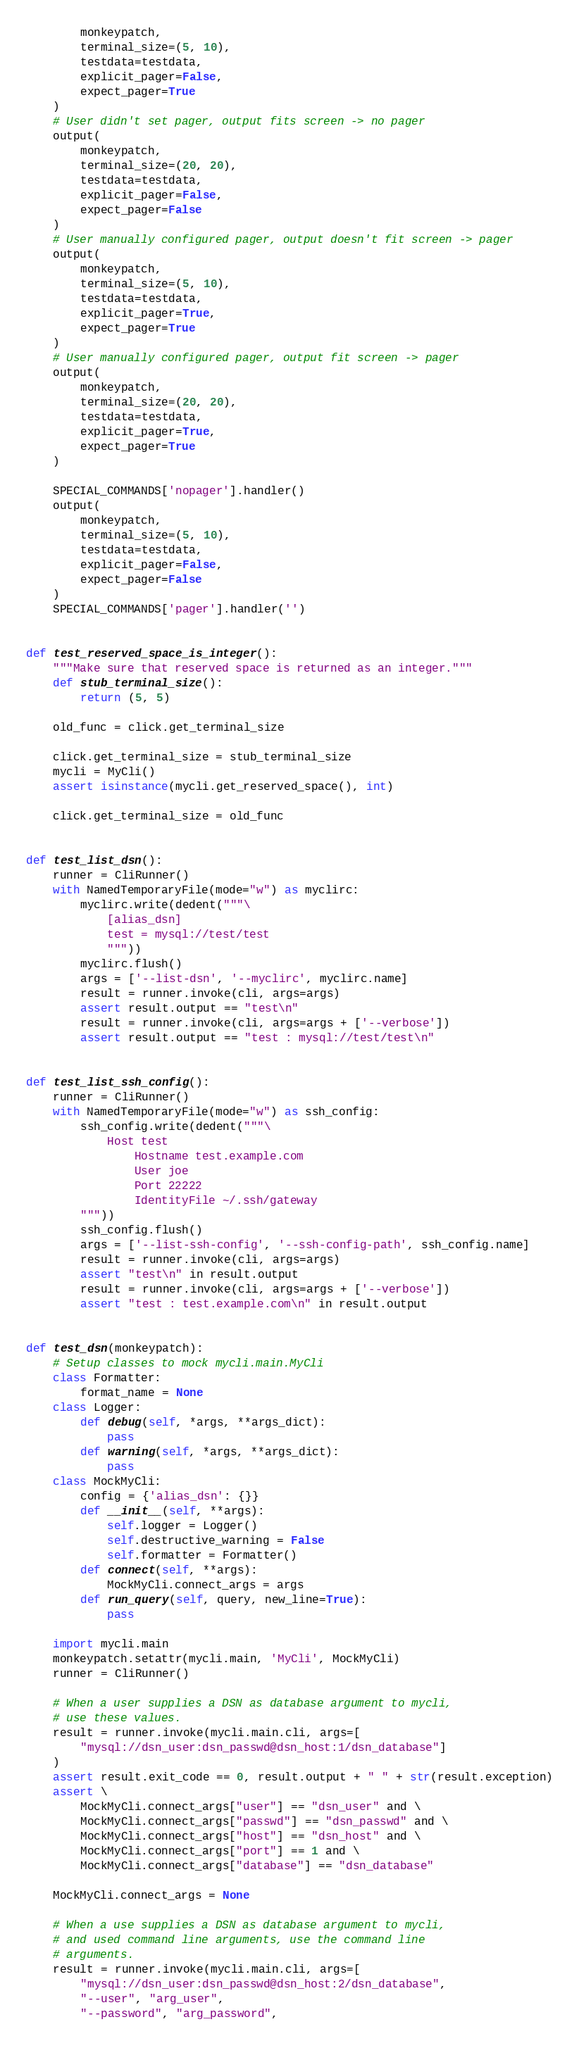Convert code to text. <code><loc_0><loc_0><loc_500><loc_500><_Python_>        monkeypatch,
        terminal_size=(5, 10),
        testdata=testdata,
        explicit_pager=False,
        expect_pager=True
    )
    # User didn't set pager, output fits screen -> no pager
    output(
        monkeypatch,
        terminal_size=(20, 20),
        testdata=testdata,
        explicit_pager=False,
        expect_pager=False
    )
    # User manually configured pager, output doesn't fit screen -> pager
    output(
        monkeypatch,
        terminal_size=(5, 10),
        testdata=testdata,
        explicit_pager=True,
        expect_pager=True
    )
    # User manually configured pager, output fit screen -> pager
    output(
        monkeypatch,
        terminal_size=(20, 20),
        testdata=testdata,
        explicit_pager=True,
        expect_pager=True
    )

    SPECIAL_COMMANDS['nopager'].handler()
    output(
        monkeypatch,
        terminal_size=(5, 10),
        testdata=testdata,
        explicit_pager=False,
        expect_pager=False
    )
    SPECIAL_COMMANDS['pager'].handler('')


def test_reserved_space_is_integer():
    """Make sure that reserved space is returned as an integer."""
    def stub_terminal_size():
        return (5, 5)

    old_func = click.get_terminal_size

    click.get_terminal_size = stub_terminal_size
    mycli = MyCli()
    assert isinstance(mycli.get_reserved_space(), int)

    click.get_terminal_size = old_func


def test_list_dsn():
    runner = CliRunner()
    with NamedTemporaryFile(mode="w") as myclirc:
        myclirc.write(dedent("""\
            [alias_dsn]
            test = mysql://test/test
            """))
        myclirc.flush()
        args = ['--list-dsn', '--myclirc', myclirc.name]
        result = runner.invoke(cli, args=args)
        assert result.output == "test\n"
        result = runner.invoke(cli, args=args + ['--verbose'])
        assert result.output == "test : mysql://test/test\n"


def test_list_ssh_config():
    runner = CliRunner()
    with NamedTemporaryFile(mode="w") as ssh_config:
        ssh_config.write(dedent("""\
            Host test
                Hostname test.example.com
                User joe
                Port 22222
                IdentityFile ~/.ssh/gateway
        """))
        ssh_config.flush()
        args = ['--list-ssh-config', '--ssh-config-path', ssh_config.name]
        result = runner.invoke(cli, args=args)
        assert "test\n" in result.output
        result = runner.invoke(cli, args=args + ['--verbose'])
        assert "test : test.example.com\n" in result.output


def test_dsn(monkeypatch):
    # Setup classes to mock mycli.main.MyCli
    class Formatter:
        format_name = None
    class Logger:
        def debug(self, *args, **args_dict):
            pass
        def warning(self, *args, **args_dict):
            pass
    class MockMyCli:
        config = {'alias_dsn': {}}
        def __init__(self, **args):
            self.logger = Logger()
            self.destructive_warning = False
            self.formatter = Formatter()
        def connect(self, **args):
            MockMyCli.connect_args = args
        def run_query(self, query, new_line=True):
            pass

    import mycli.main
    monkeypatch.setattr(mycli.main, 'MyCli', MockMyCli)
    runner = CliRunner()

    # When a user supplies a DSN as database argument to mycli,
    # use these values.
    result = runner.invoke(mycli.main.cli, args=[
        "mysql://dsn_user:dsn_passwd@dsn_host:1/dsn_database"]
    )
    assert result.exit_code == 0, result.output + " " + str(result.exception)
    assert \
        MockMyCli.connect_args["user"] == "dsn_user" and \
        MockMyCli.connect_args["passwd"] == "dsn_passwd" and \
        MockMyCli.connect_args["host"] == "dsn_host" and \
        MockMyCli.connect_args["port"] == 1 and \
        MockMyCli.connect_args["database"] == "dsn_database"

    MockMyCli.connect_args = None

    # When a use supplies a DSN as database argument to mycli,
    # and used command line arguments, use the command line
    # arguments.
    result = runner.invoke(mycli.main.cli, args=[
        "mysql://dsn_user:dsn_passwd@dsn_host:2/dsn_database",
        "--user", "arg_user",
        "--password", "arg_password",</code> 